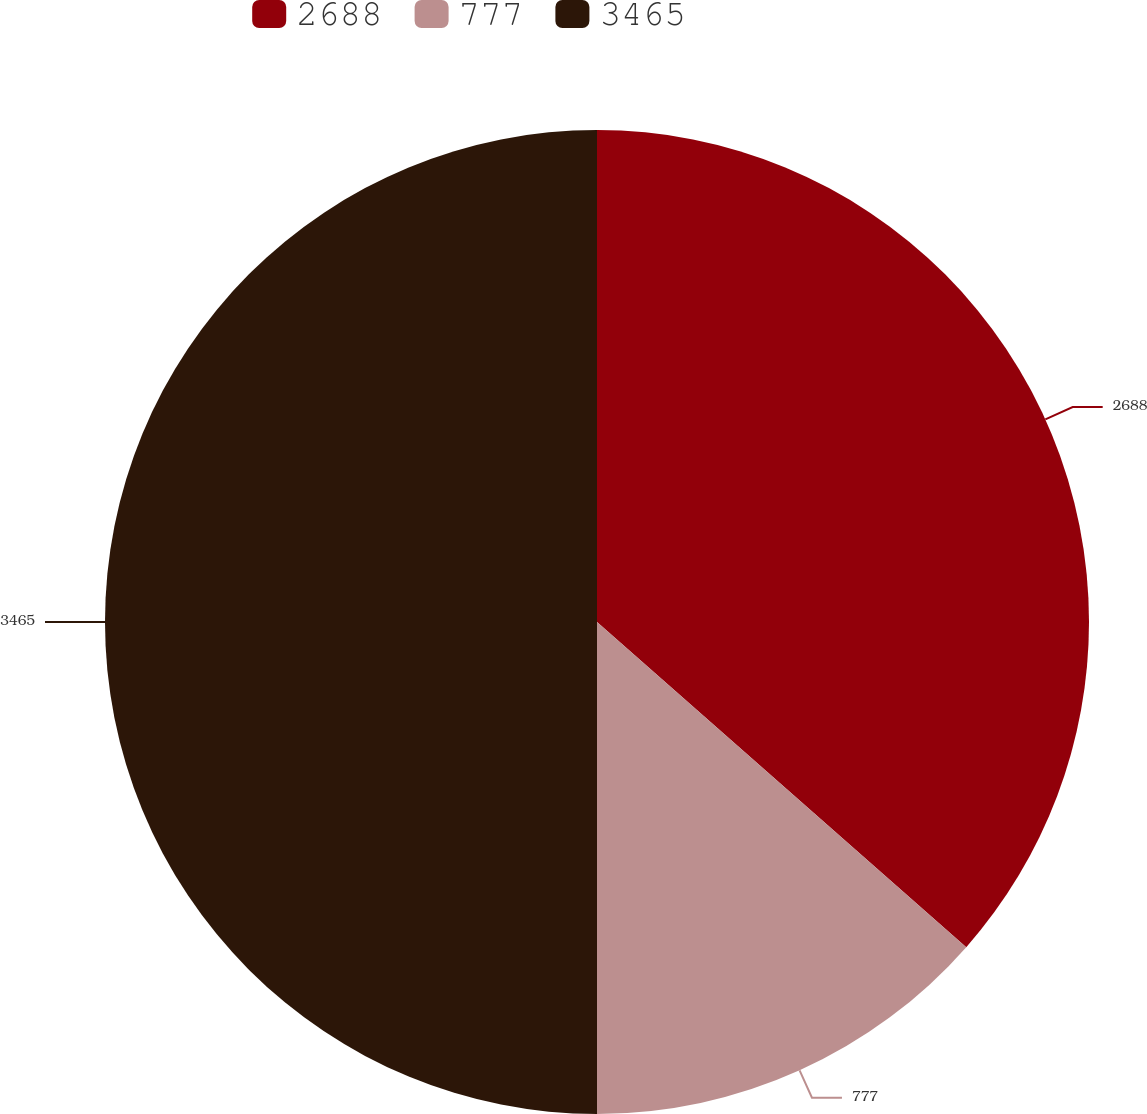Convert chart. <chart><loc_0><loc_0><loc_500><loc_500><pie_chart><fcel>2688<fcel>777<fcel>3465<nl><fcel>36.49%<fcel>13.51%<fcel>50.0%<nl></chart> 